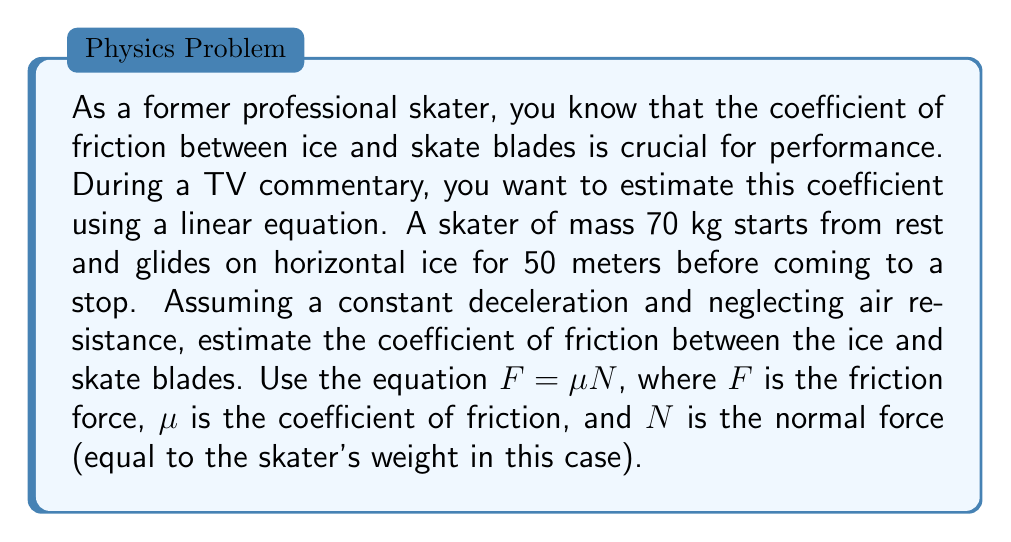Can you solve this math problem? To solve this problem, we'll follow these steps:

1) First, we need to find the deceleration of the skater. We can use the equation of motion:

   $$v^2 = u^2 + 2as$$

   Where $v$ is final velocity (0 m/s), $u$ is initial velocity (0 m/s), $a$ is acceleration (deceleration in this case), and $s$ is distance (50 m).

2) Substituting the values:

   $$0^2 = 0^2 + 2a(50)$$
   $$0 = 100a$$
   $$a = -\frac{1}{2} \text{ m/s}^2$$

   The negative sign indicates deceleration.

3) Now, we can use Newton's Second Law to find the friction force:

   $$F = ma = 70 \cdot (-\frac{1}{2}) = -35 \text{ N}$$

4) The normal force $N$ is equal to the skater's weight:

   $$N = mg = 70 \cdot 9.8 = 686 \text{ N}$$

5) Now we can use the equation $F = \mu N$ to find $\mu$:

   $$-35 = \mu \cdot 686$$
   $$\mu = \frac{-35}{686} \approx 0.051$$

The negative sign in the friction force is due to its direction being opposite to motion. We take the absolute value for the coefficient of friction.
Answer: The estimated coefficient of friction between the ice and skate blades is approximately 0.051. 